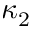<formula> <loc_0><loc_0><loc_500><loc_500>\kappa _ { 2 }</formula> 